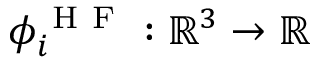Convert formula to latex. <formula><loc_0><loc_0><loc_500><loc_500>\phi _ { i } ^ { H F } \colon \mathbb { R } ^ { 3 } \rightarrow \mathbb { R }</formula> 